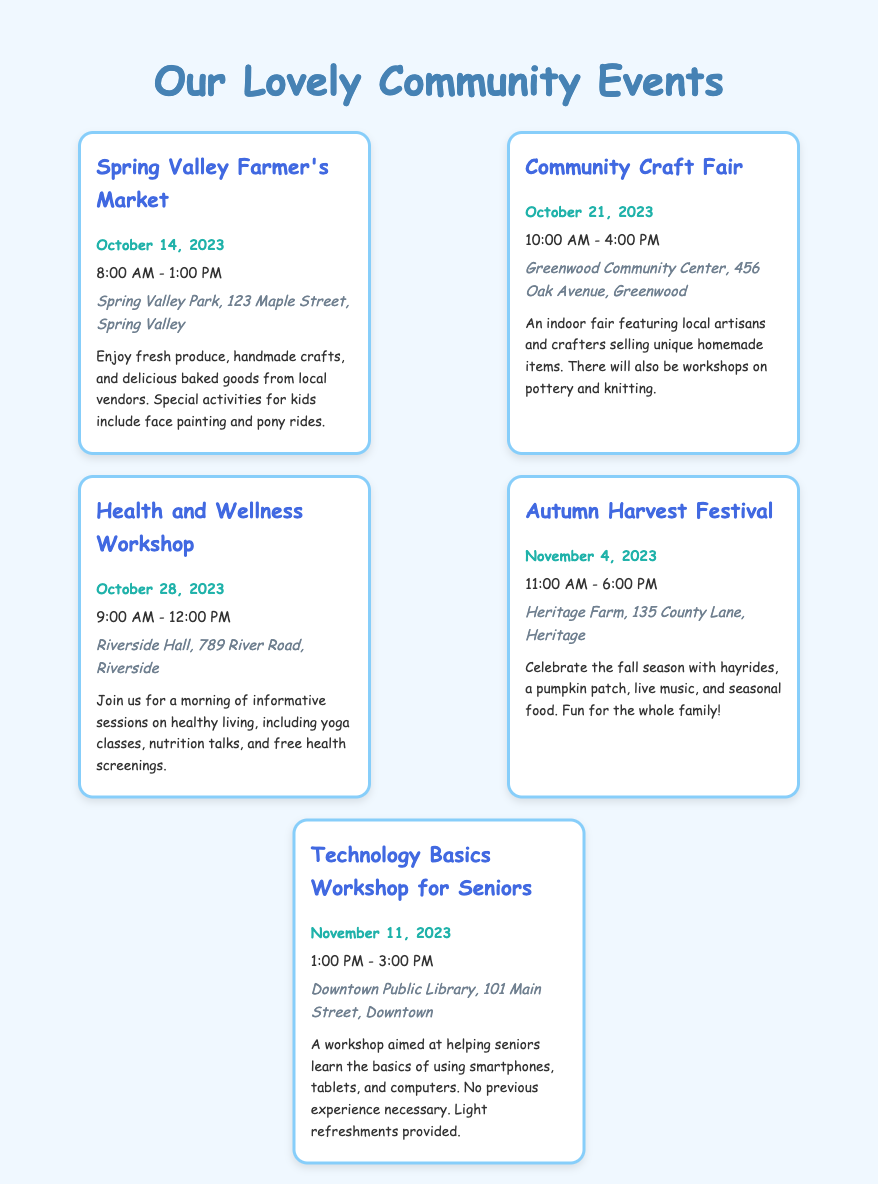What is the date of the Spring Valley Farmer's Market? The date for the Spring Valley Farmer's Market is specifically mentioned in the document, which is October 14, 2023.
Answer: October 14, 2023 What time does the Community Craft Fair begin? The document states that the Community Craft Fair starts at 10:00 AM on October 21, 2023.
Answer: 10:00 AM Where is the Health and Wellness Workshop taking place? The venue for the Health and Wellness Workshop is listed as Riverside Hall, 789 River Road, Riverside.
Answer: Riverside Hall, 789 River Road, Riverside Which event includes face painting for kids? The Spring Valley Farmer's Market has special activities for kids, including face painting.
Answer: Spring Valley Farmer's Market How long does the Autumn Harvest Festival last? According to the document, the Autumn Harvest Festival lasts from 11:00 AM to 6:00 PM, making it a total of 7 hours.
Answer: 7 hours What is the main focus of the Technology Basics Workshop for Seniors? The workshop aims at helping seniors learn the basics of using smartphones, tablets, and computers.
Answer: Using smartphones, tablets, and computers How many community events are listed in this document? By counting each event mentioned in the document, we find that there are a total of 5 events listed.
Answer: 5 events What type of activities will be available at the Autumn Harvest Festival? The Autumn Harvest Festival includes hayrides, a pumpkin patch, live music, and seasonal food.
Answer: Hayrides, pumpkin patch, live music, seasonal food When is the next event after the Health and Wellness Workshop? The next event following the Health and Wellness Workshop is the Autumn Harvest Festival on November 4, 2023.
Answer: November 4, 2023 